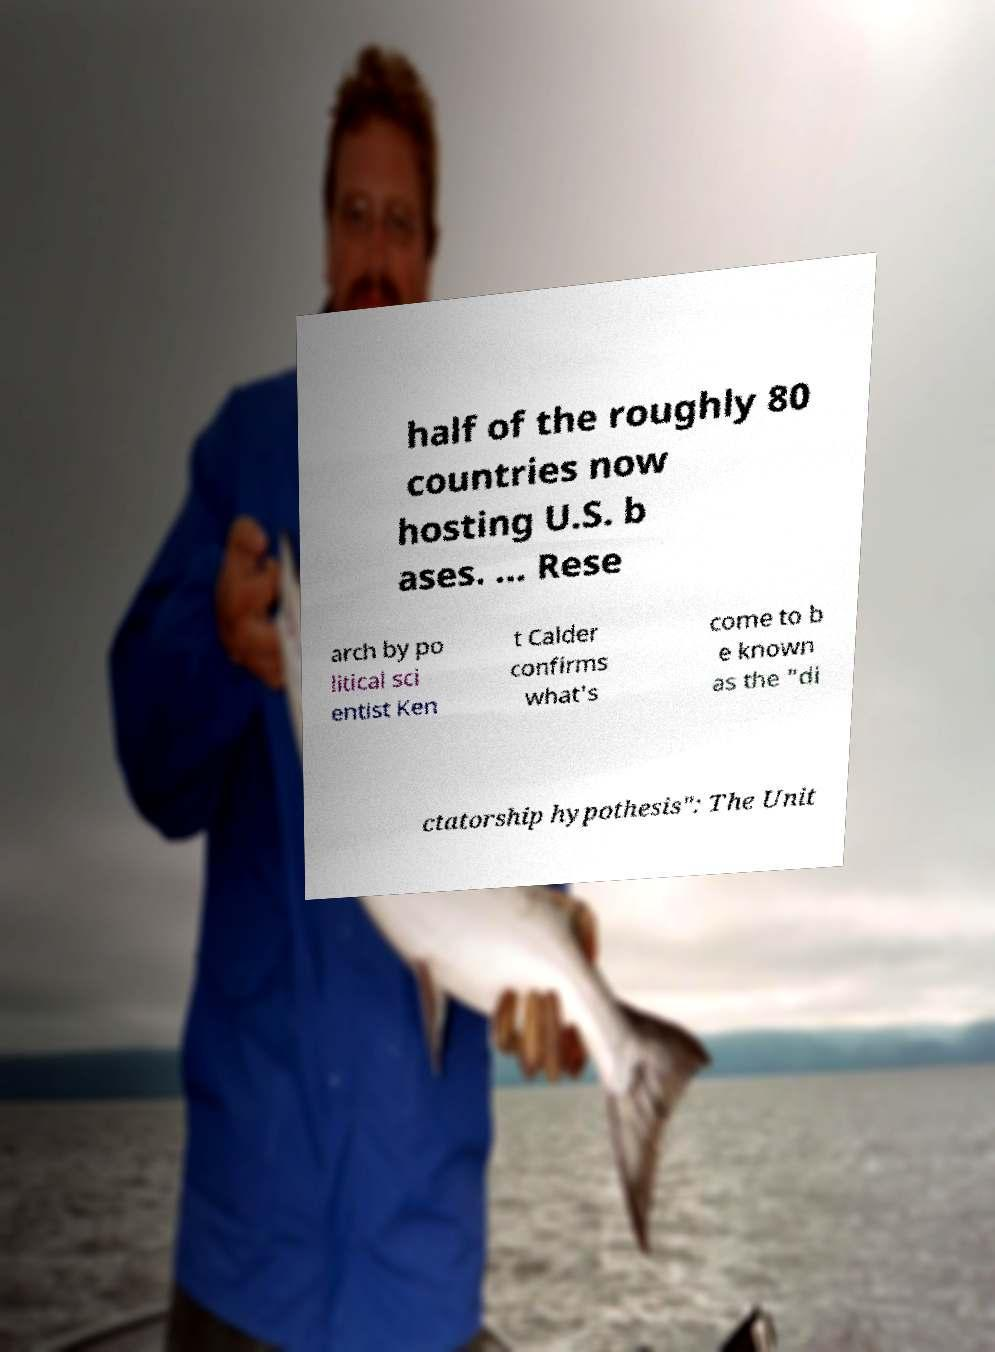Please read and relay the text visible in this image. What does it say? half of the roughly 80 countries now hosting U.S. b ases. ... Rese arch by po litical sci entist Ken t Calder confirms what's come to b e known as the "di ctatorship hypothesis": The Unit 